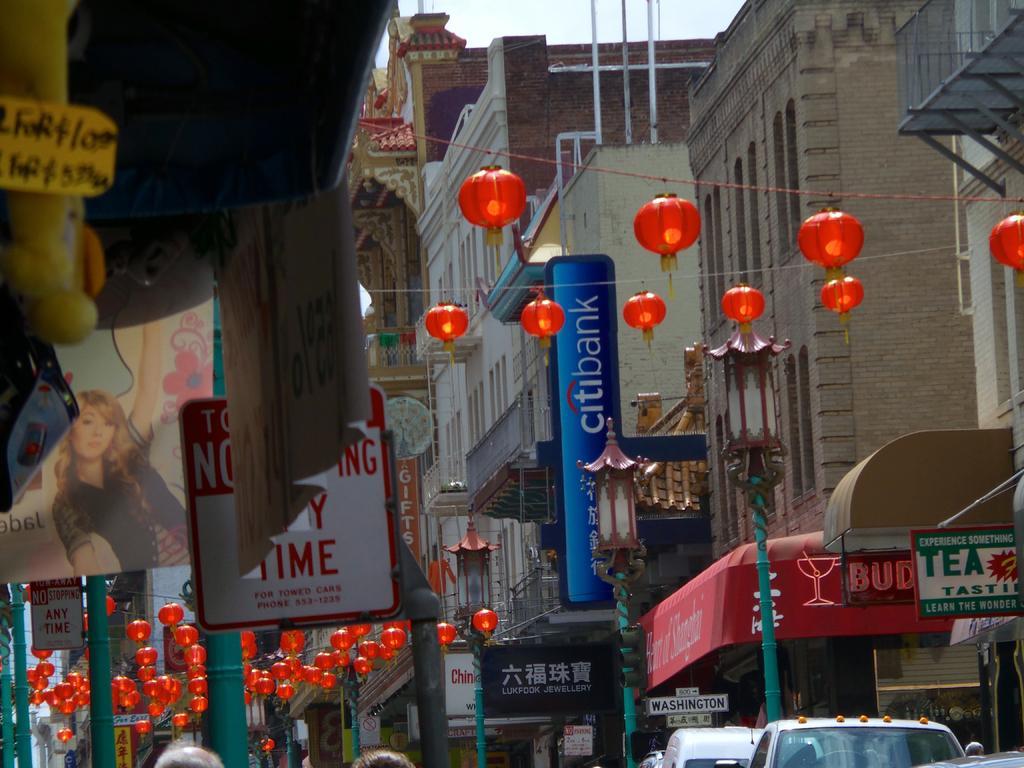Can you describe this image briefly? In this image there are vehicles and buildings, for that buildings there are posters, on that posters there are some text and pictures at the top there are lights hanged to threads. 